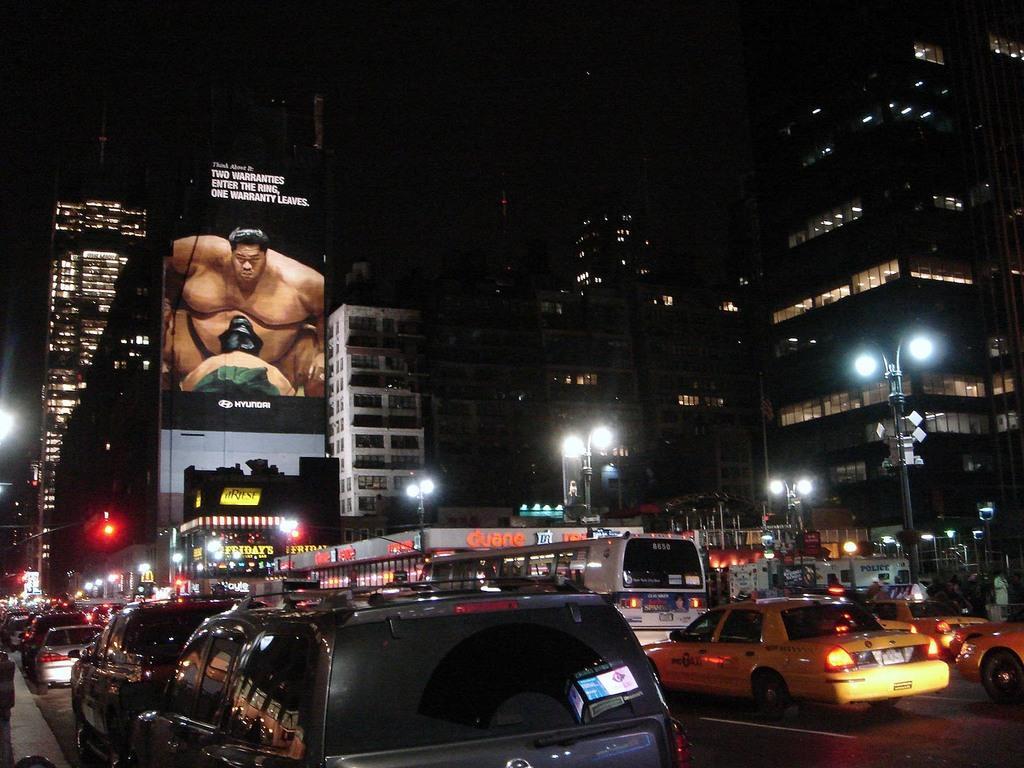How would you summarize this image in a sentence or two? In this image we can see buildings and lights, there are poles. At the bottom we can see vehicles on the road and there is a board. 